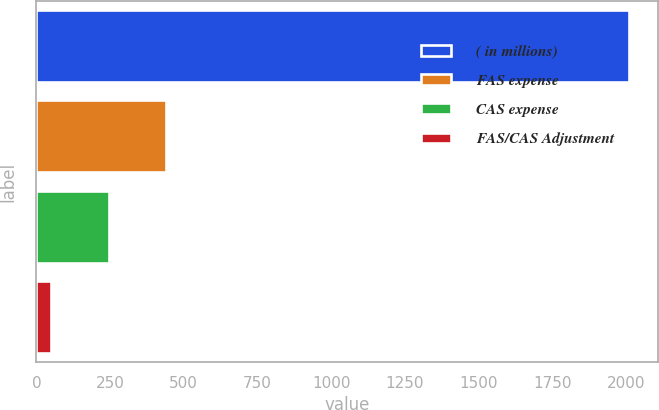Convert chart to OTSL. <chart><loc_0><loc_0><loc_500><loc_500><bar_chart><fcel>( in millions)<fcel>FAS expense<fcel>CAS expense<fcel>FAS/CAS Adjustment<nl><fcel>2010<fcel>441.2<fcel>245.1<fcel>49<nl></chart> 